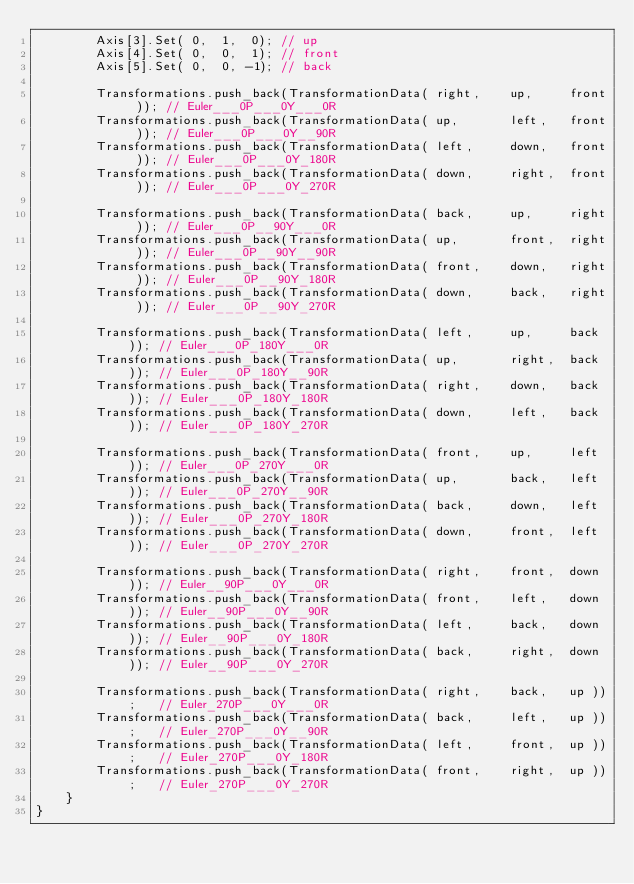Convert code to text. <code><loc_0><loc_0><loc_500><loc_500><_C++_>		Axis[3].Set( 0,  1,  0); // up
		Axis[4].Set( 0,  0,  1); // front
		Axis[5].Set( 0,  0, -1); // back

		Transformations.push_back(TransformationData( right,	up,		front )); // Euler___0P___0Y___0R
		Transformations.push_back(TransformationData( up,		left,	front )); // Euler___0P___0Y__90R
		Transformations.push_back(TransformationData( left,		down,	front )); // Euler___0P___0Y_180R
		Transformations.push_back(TransformationData( down,		right,	front )); // Euler___0P___0Y_270R
		
		Transformations.push_back(TransformationData( back,		up,		right )); // Euler___0P__90Y___0R
		Transformations.push_back(TransformationData( up,		front,	right )); // Euler___0P__90Y__90R
		Transformations.push_back(TransformationData( front,	down,	right )); // Euler___0P__90Y_180R
		Transformations.push_back(TransformationData( down,		back,	right )); // Euler___0P__90Y_270R
		
		Transformations.push_back(TransformationData( left,		up,		back )); // Euler___0P_180Y___0R
		Transformations.push_back(TransformationData( up,		right,	back )); // Euler___0P_180Y__90R
		Transformations.push_back(TransformationData( right,	down,	back )); // Euler___0P_180Y_180R
		Transformations.push_back(TransformationData( down,		left,	back )); // Euler___0P_180Y_270R
		
		Transformations.push_back(TransformationData( front,	up,		left )); // Euler___0P_270Y___0R
		Transformations.push_back(TransformationData( up,		back,	left )); // Euler___0P_270Y__90R
		Transformations.push_back(TransformationData( back,		down,	left )); // Euler___0P_270Y_180R
		Transformations.push_back(TransformationData( down,		front,	left )); // Euler___0P_270Y_270R
		
		Transformations.push_back(TransformationData( right,	front,	down )); // Euler__90P___0Y___0R
		Transformations.push_back(TransformationData( front,	left,	down )); // Euler__90P___0Y__90R
		Transformations.push_back(TransformationData( left,		back,	down )); // Euler__90P___0Y_180R
		Transformations.push_back(TransformationData( back,		right,	down )); // Euler__90P___0Y_270R
		
		Transformations.push_back(TransformationData( right,	back,	up ));	 // Euler_270P___0Y___0R
		Transformations.push_back(TransformationData( back,		left,	up ));	 // Euler_270P___0Y__90R
		Transformations.push_back(TransformationData( left,		front,	up ));	 // Euler_270P___0Y_180R
		Transformations.push_back(TransformationData( front,	right,	up ));	 // Euler_270P___0Y_270R
	}												  
}</code> 